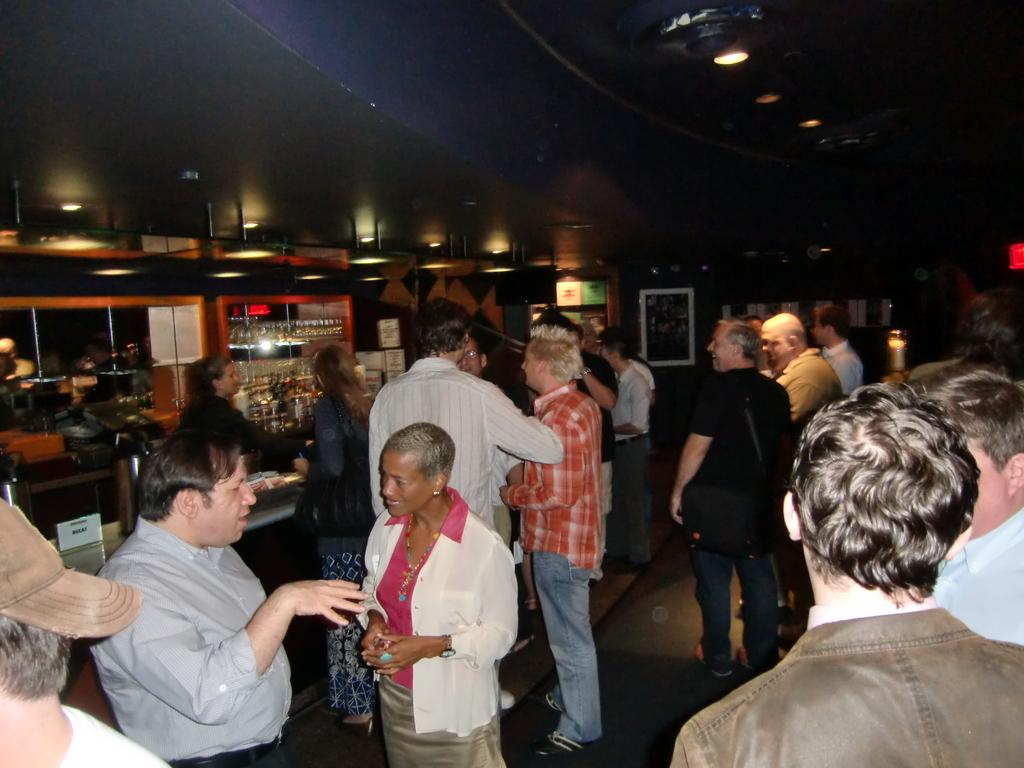What is happening in the image? There are people standing in the image. What can be seen on the shelves in the image? There are bottles on the shelves in the image. What is providing illumination in the image? There are lights visible in the image. What decorative items can be seen at the back of the image? There are photo frames at the back in the image. How many rabbits are sitting on the umbrella in the image? There are no rabbits or umbrellas present in the image. 